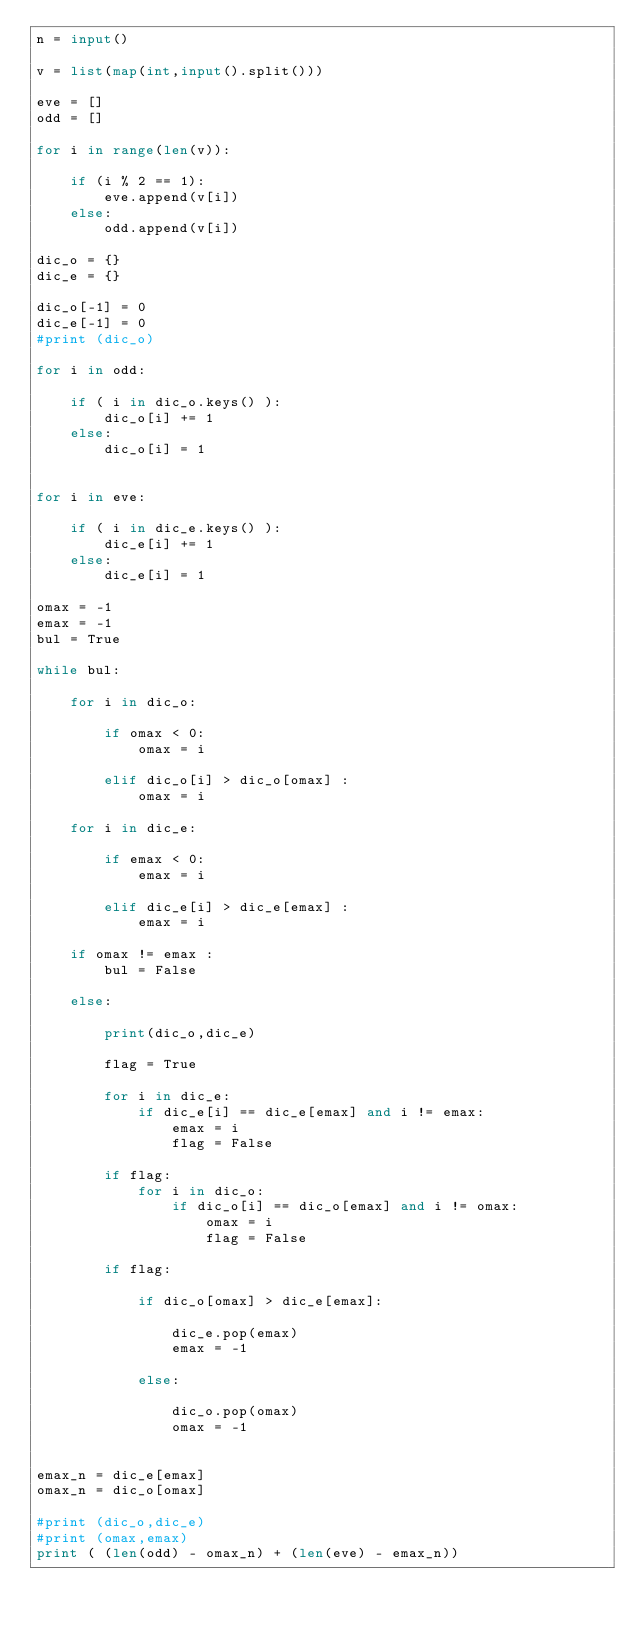Convert code to text. <code><loc_0><loc_0><loc_500><loc_500><_Python_>n = input()

v = list(map(int,input().split()))

eve = []
odd = []

for i in range(len(v)):

    if (i % 2 == 1):
        eve.append(v[i])
    else:
        odd.append(v[i])

dic_o = {}
dic_e = {}

dic_o[-1] = 0
dic_e[-1] = 0
#print (dic_o)

for i in odd:

    if ( i in dic_o.keys() ):
        dic_o[i] += 1
    else:
        dic_o[i] = 1


for i in eve:

    if ( i in dic_e.keys() ):
        dic_e[i] += 1
    else:
        dic_e[i] = 1

omax = -1
emax = -1
bul = True

while bul:

    for i in dic_o:
        
        if omax < 0:
            omax = i
        
        elif dic_o[i] > dic_o[omax] :
            omax = i

    for i in dic_e:

        if emax < 0:
            emax = i
        
        elif dic_e[i] > dic_e[emax] :
            emax = i

    if omax != emax :
        bul = False

    else:

        print(dic_o,dic_e)
        
        flag = True
        
        for i in dic_e:
            if dic_e[i] == dic_e[emax] and i != emax:
                emax = i
                flag = False

        if flag:
            for i in dic_o:
                if dic_o[i] == dic_o[emax] and i != omax:
                    omax = i
                    flag = False

        if flag:
        
            if dic_o[omax] > dic_e[emax]:
        
                dic_e.pop(emax)
                emax = -1

            else:

                dic_o.pop(omax)
                omax = -1

    
emax_n = dic_e[emax]
omax_n = dic_o[omax]

#print (dic_o,dic_e)
#print (omax,emax)
print ( (len(odd) - omax_n) + (len(eve) - emax_n))
</code> 